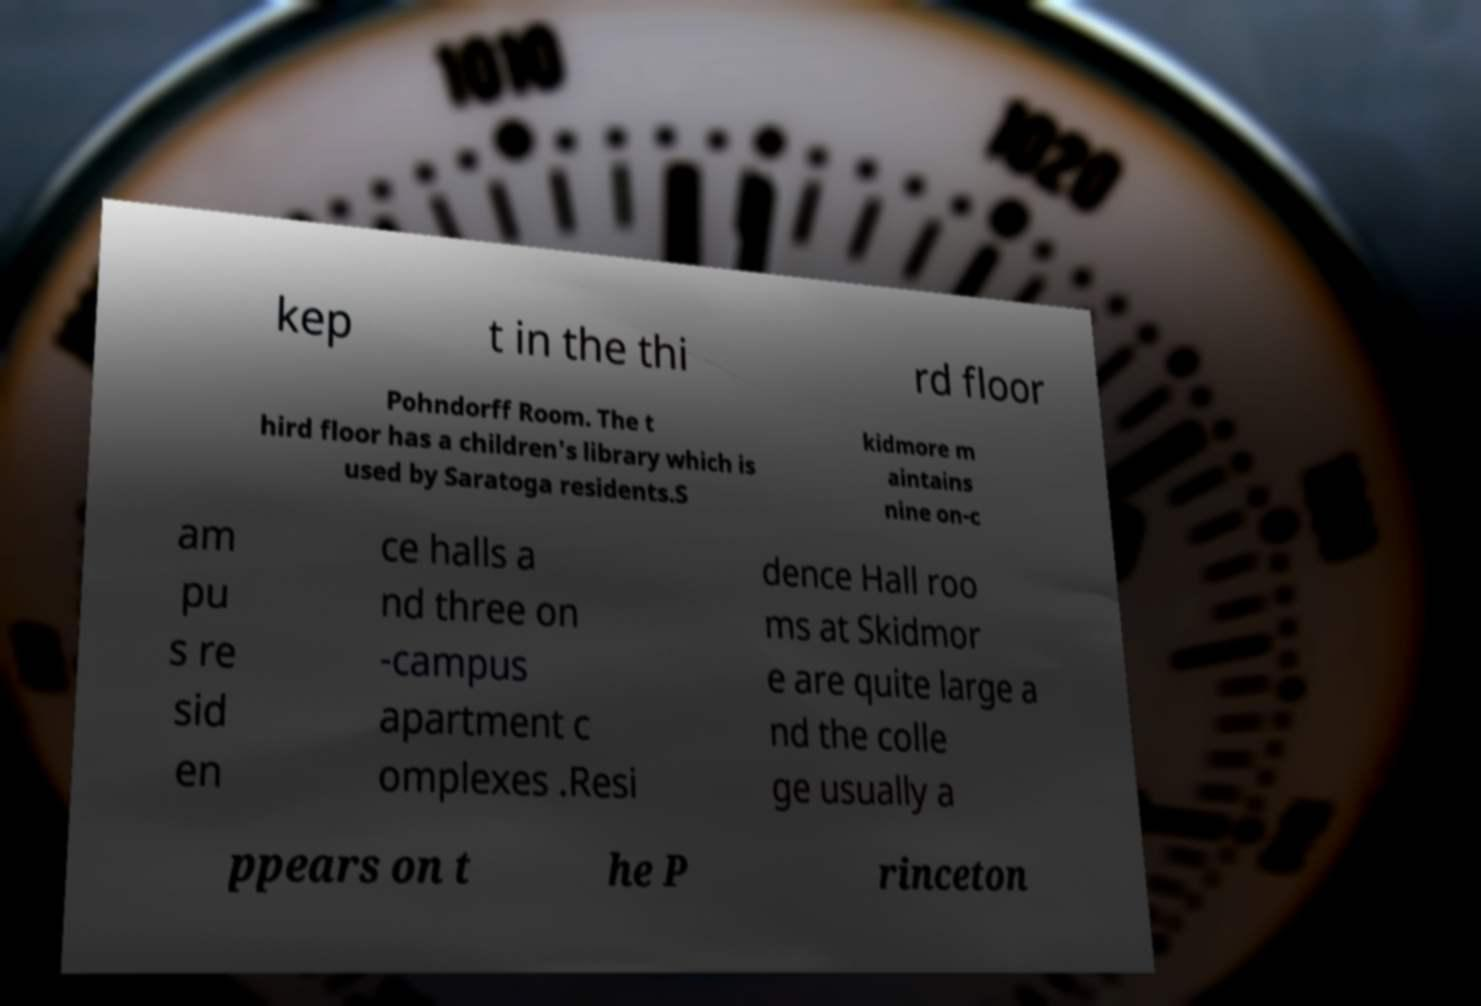For documentation purposes, I need the text within this image transcribed. Could you provide that? kep t in the thi rd floor Pohndorff Room. The t hird floor has a children's library which is used by Saratoga residents.S kidmore m aintains nine on-c am pu s re sid en ce halls a nd three on -campus apartment c omplexes .Resi dence Hall roo ms at Skidmor e are quite large a nd the colle ge usually a ppears on t he P rinceton 